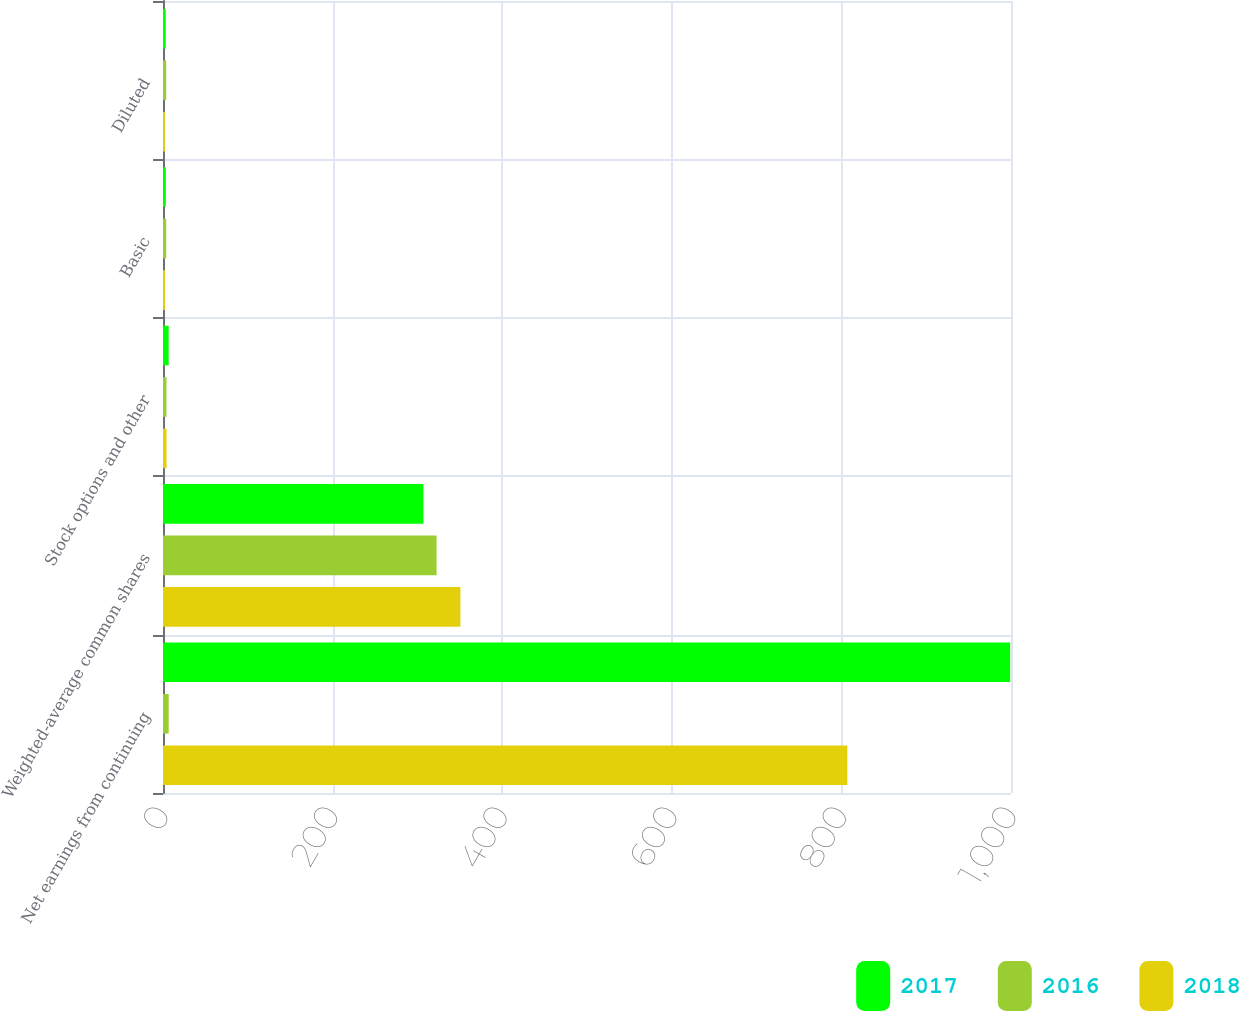Convert chart to OTSL. <chart><loc_0><loc_0><loc_500><loc_500><stacked_bar_chart><ecel><fcel>Net earnings from continuing<fcel>Weighted-average common shares<fcel>Stock options and other<fcel>Basic<fcel>Diluted<nl><fcel>2017<fcel>999<fcel>307.1<fcel>6.7<fcel>3.33<fcel>3.26<nl><fcel>2016<fcel>6.7<fcel>322.6<fcel>4.1<fcel>3.79<fcel>3.74<nl><fcel>2018<fcel>807<fcel>350.7<fcel>4.2<fcel>2.33<fcel>2.3<nl></chart> 